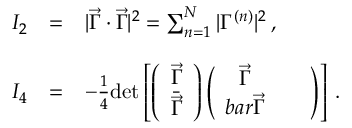Convert formula to latex. <formula><loc_0><loc_0><loc_500><loc_500>\begin{array} { r c l } { { I _ { 2 } } } & { = } & { { | \vec { \Gamma } \cdot \vec { \Gamma } | ^ { 2 } = \sum _ { n = 1 } ^ { N } | \Gamma ^ { ( n ) } | ^ { 2 } \, , } } \\ { { I _ { 4 } } } & { = } & { { - \frac { 1 } { 4 } d e t \left [ \left ( \begin{array} { c } { { \vec { \Gamma } } } \\ { { \bar { \vec { \Gamma } } } } \end{array} \right ) \left ( \begin{array} { c c } { { \vec { \Gamma } } } & { \ \ } \\ { { b a r { \vec { \Gamma } } } } \end{array} \right ) \right ] \, . } } \end{array}</formula> 